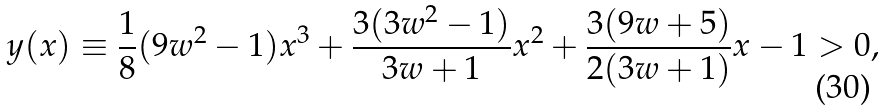Convert formula to latex. <formula><loc_0><loc_0><loc_500><loc_500>y ( x ) \equiv \frac { 1 } { 8 } ( 9 w ^ { 2 } - 1 ) x ^ { 3 } + \frac { 3 ( 3 w ^ { 2 } - 1 ) } { 3 w + 1 } x ^ { 2 } + \frac { 3 ( 9 w + 5 ) } { 2 ( 3 w + 1 ) } x - 1 > 0 ,</formula> 